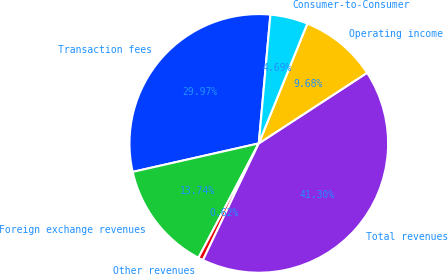Convert chart. <chart><loc_0><loc_0><loc_500><loc_500><pie_chart><fcel>Transaction fees<fcel>Foreign exchange revenues<fcel>Other revenues<fcel>Total revenues<fcel>Operating income<fcel>Consumer-to-Consumer<nl><fcel>29.97%<fcel>13.74%<fcel>0.62%<fcel>41.3%<fcel>9.68%<fcel>4.69%<nl></chart> 